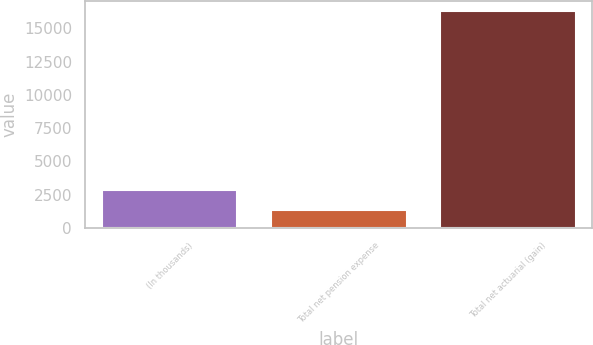Convert chart to OTSL. <chart><loc_0><loc_0><loc_500><loc_500><bar_chart><fcel>(In thousands)<fcel>Total net pension expense<fcel>Total net actuarial (gain)<nl><fcel>2833.7<fcel>1341<fcel>16268<nl></chart> 